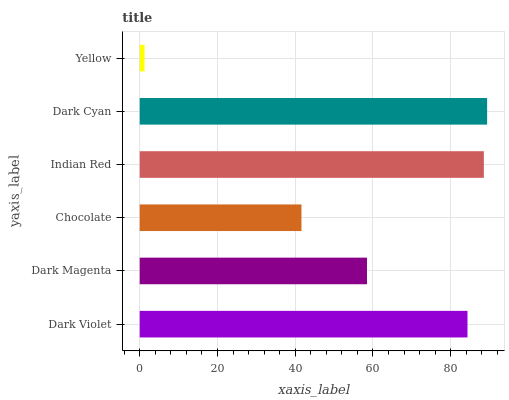Is Yellow the minimum?
Answer yes or no. Yes. Is Dark Cyan the maximum?
Answer yes or no. Yes. Is Dark Magenta the minimum?
Answer yes or no. No. Is Dark Magenta the maximum?
Answer yes or no. No. Is Dark Violet greater than Dark Magenta?
Answer yes or no. Yes. Is Dark Magenta less than Dark Violet?
Answer yes or no. Yes. Is Dark Magenta greater than Dark Violet?
Answer yes or no. No. Is Dark Violet less than Dark Magenta?
Answer yes or no. No. Is Dark Violet the high median?
Answer yes or no. Yes. Is Dark Magenta the low median?
Answer yes or no. Yes. Is Dark Cyan the high median?
Answer yes or no. No. Is Chocolate the low median?
Answer yes or no. No. 